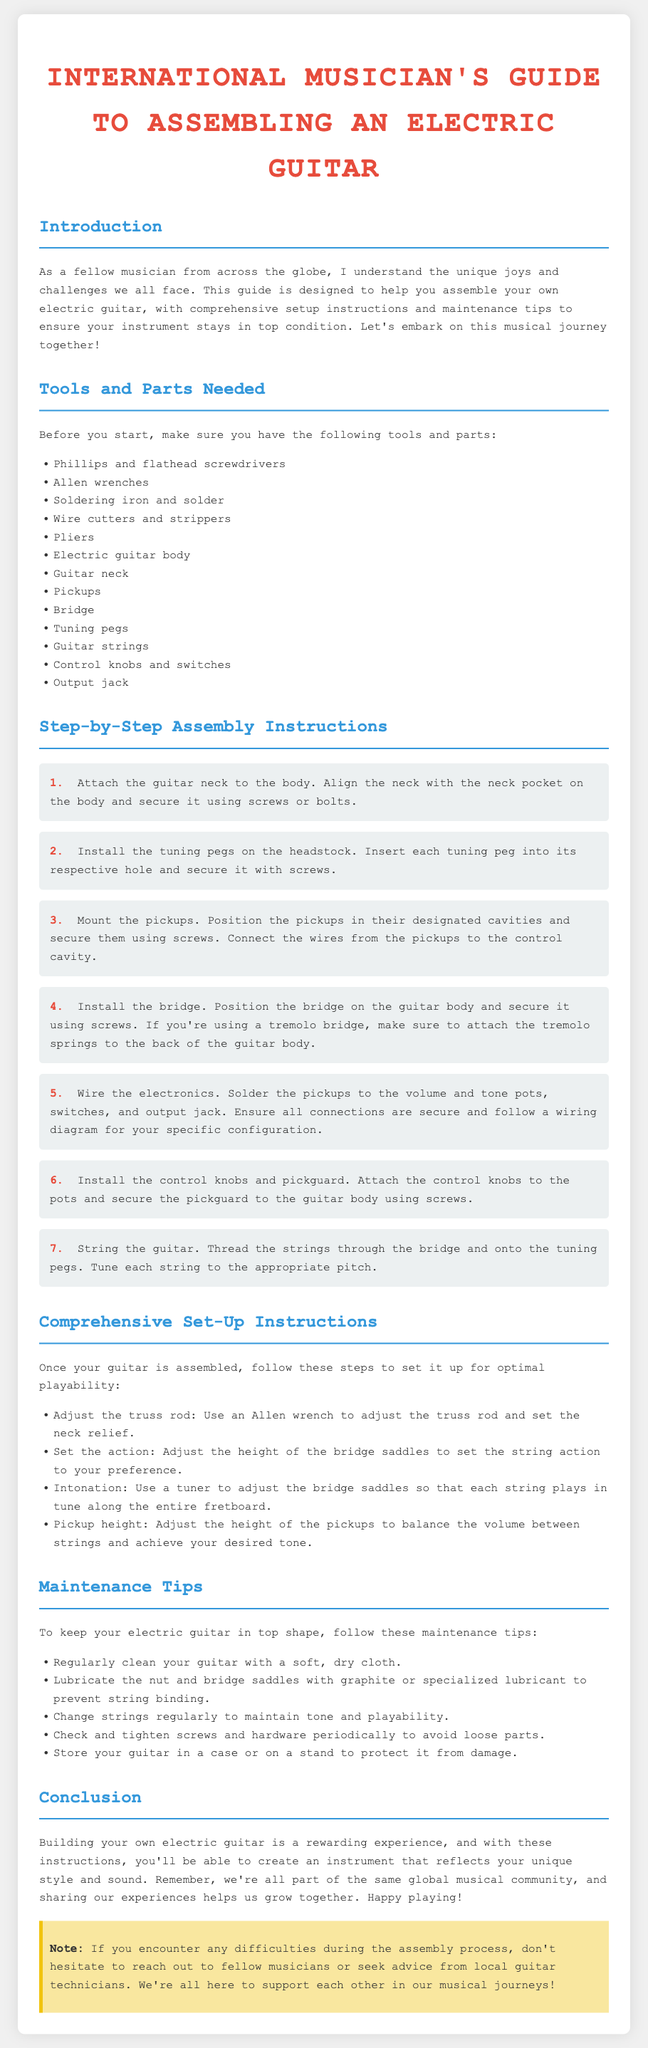What tools are needed for assembly? The document lists a variety of tools required for the assembly process, including screwdrivers, soldering iron, and wire cutters.
Answer: Phillips and flathead screwdrivers, Allen wrenches, soldering iron, wire cutters, pliers, electric guitar body, guitar neck, pickups, bridge, tuning pegs, guitar strings, control knobs, output jack How many steps are in the assembly instructions? The document outlines a series of step-by-step instructions, specifically enumerating each crucial step in the assembly process.
Answer: 7 What should you adjust to set the neck relief? The maintenance section includes instructions for optimizing the guitar's playability with specific adjustments.
Answer: Truss rod What is the purpose of soldering the pickups? The instructions on wiring electronics indicate a specific need for soldering connections to ensure they function properly.
Answer: To connect the pickups to the volume and tone pots What is a recommended maintenance tip for the guitar? The document provides several maintenance tips to ensure the guitar remains in good condition by regularly performing certain actions.
Answer: Regularly clean your guitar with a soft, dry cloth 